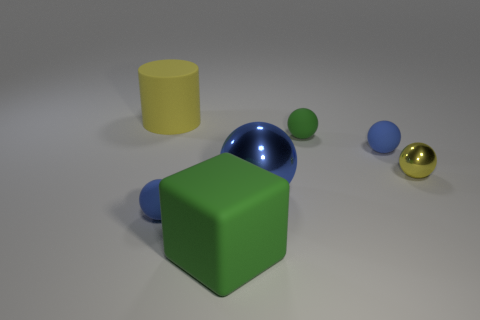There is a rubber thing that is the same color as the large matte cube; what is its shape?
Make the answer very short. Sphere. What number of other red rubber cylinders are the same size as the rubber cylinder?
Your answer should be very brief. 0. There is a big object that is right of the big yellow rubber thing and to the left of the big ball; what color is it?
Offer a terse response. Green. Is the number of cylinders in front of the big green matte object greater than the number of metal things?
Offer a terse response. No. Are there any tiny green blocks?
Keep it short and to the point. No. Is the color of the rubber block the same as the big sphere?
Provide a short and direct response. No. How many tiny objects are rubber things or yellow metallic things?
Offer a very short reply. 4. Is there any other thing that is the same color as the matte cube?
Offer a very short reply. Yes. What is the shape of the large object that is made of the same material as the yellow cylinder?
Offer a very short reply. Cube. There is a yellow object that is right of the big green matte thing; what is its size?
Provide a succinct answer. Small. 